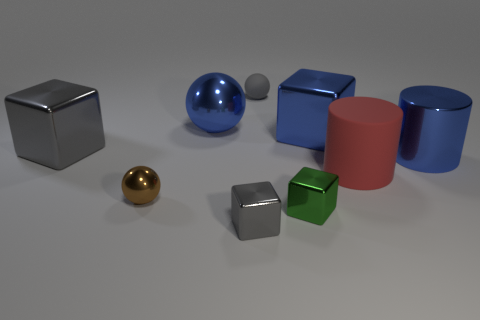Subtract all big metallic balls. How many balls are left? 2 Subtract all brown spheres. How many spheres are left? 2 Add 1 small balls. How many objects exist? 10 Subtract 3 blocks. How many blocks are left? 1 Subtract all cylinders. How many objects are left? 7 Subtract 0 yellow cubes. How many objects are left? 9 Subtract all red blocks. Subtract all gray cylinders. How many blocks are left? 4 Subtract all green cylinders. How many blue blocks are left? 1 Subtract all gray matte things. Subtract all large shiny cylinders. How many objects are left? 7 Add 3 small brown shiny objects. How many small brown shiny objects are left? 4 